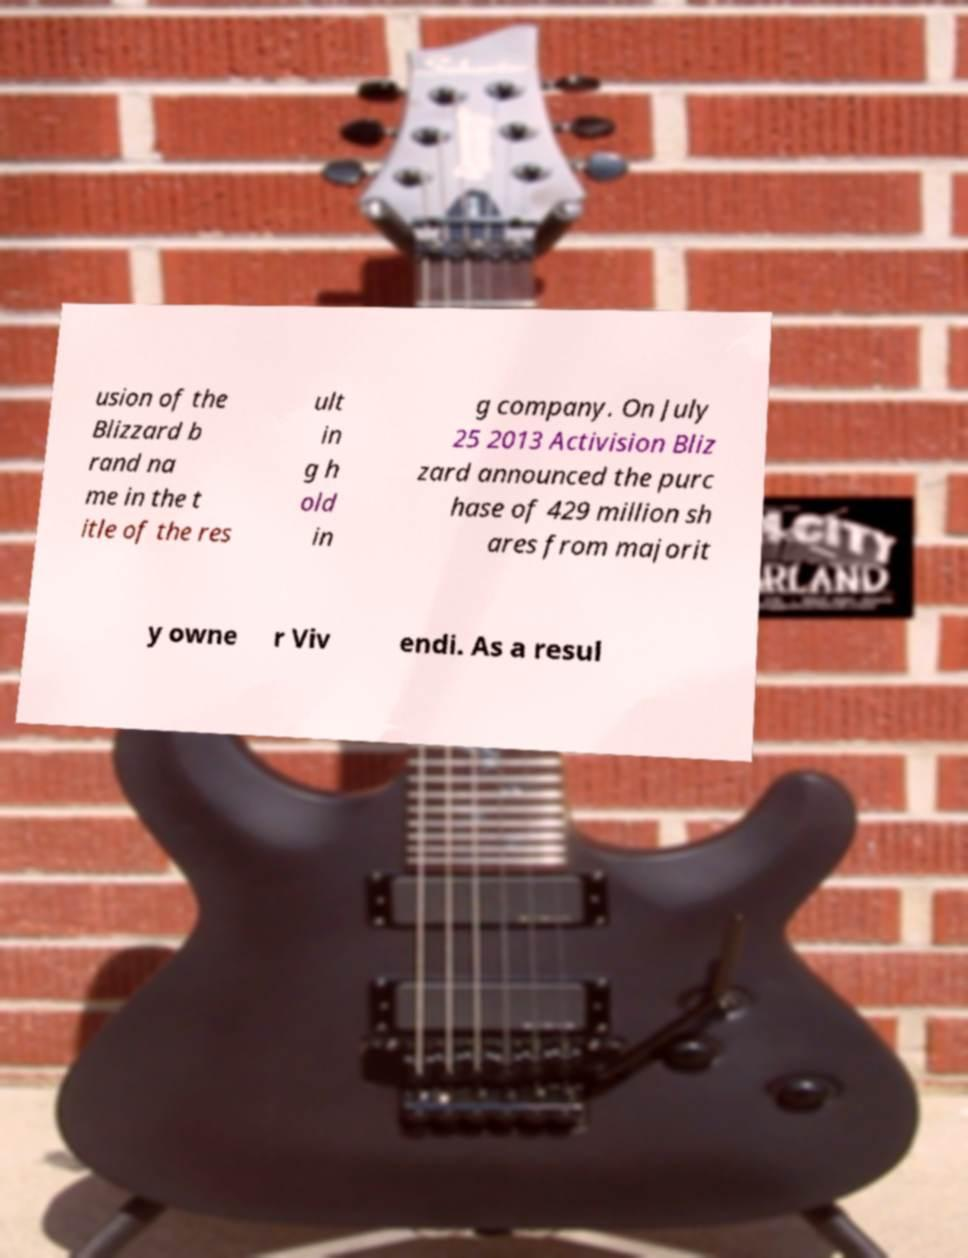For documentation purposes, I need the text within this image transcribed. Could you provide that? usion of the Blizzard b rand na me in the t itle of the res ult in g h old in g company. On July 25 2013 Activision Bliz zard announced the purc hase of 429 million sh ares from majorit y owne r Viv endi. As a resul 